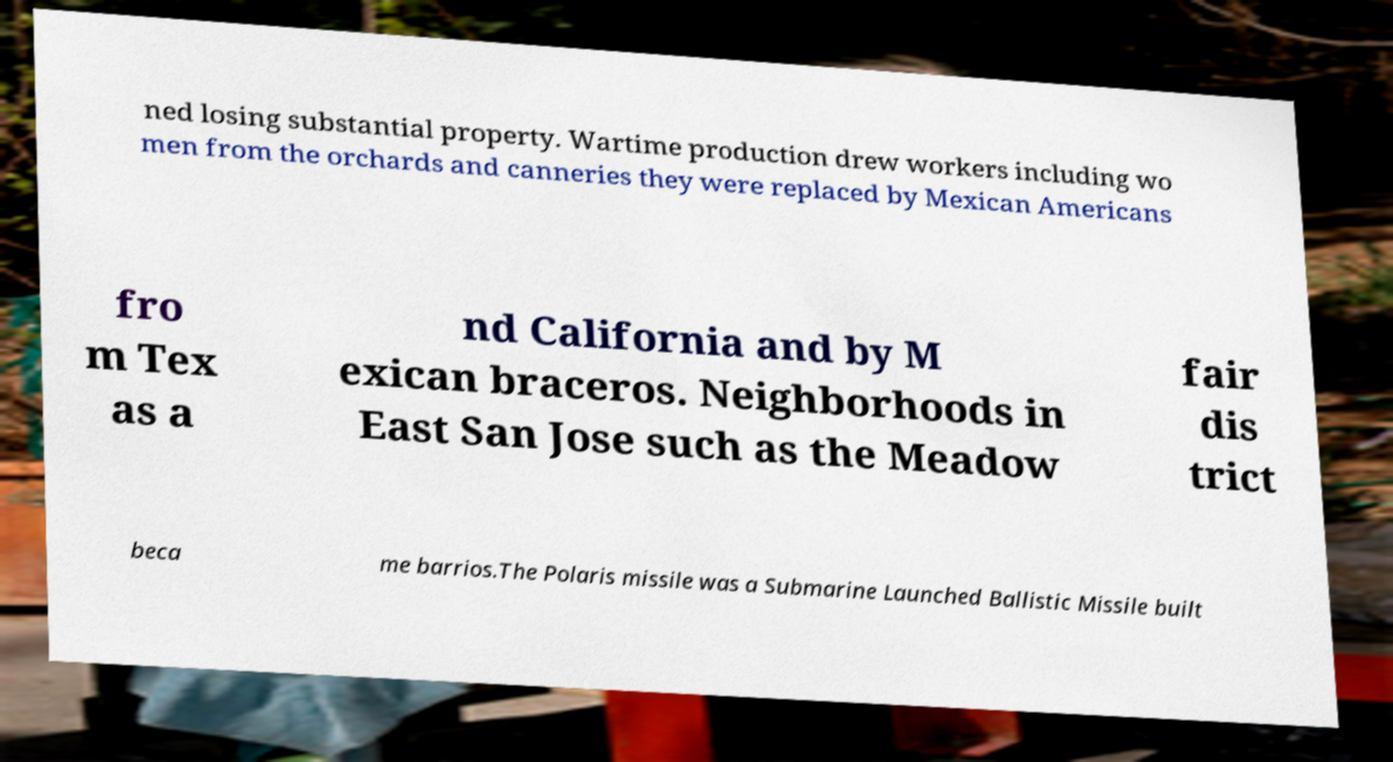Could you extract and type out the text from this image? ned losing substantial property. Wartime production drew workers including wo men from the orchards and canneries they were replaced by Mexican Americans fro m Tex as a nd California and by M exican braceros. Neighborhoods in East San Jose such as the Meadow fair dis trict beca me barrios.The Polaris missile was a Submarine Launched Ballistic Missile built 